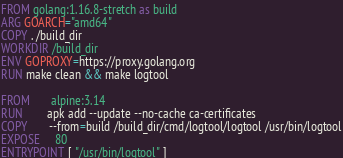<code> <loc_0><loc_0><loc_500><loc_500><_Dockerfile_>FROM golang:1.16.8-stretch as build
ARG GOARCH="amd64"
COPY . /build_dir
WORKDIR /build_dir
ENV GOPROXY=https://proxy.golang.org
RUN make clean && make logtool

FROM       alpine:3.14
RUN        apk add --update --no-cache ca-certificates
COPY       --from=build /build_dir/cmd/logtool/logtool /usr/bin/logtool
EXPOSE     80
ENTRYPOINT [ "/usr/bin/logtool" ]
</code> 